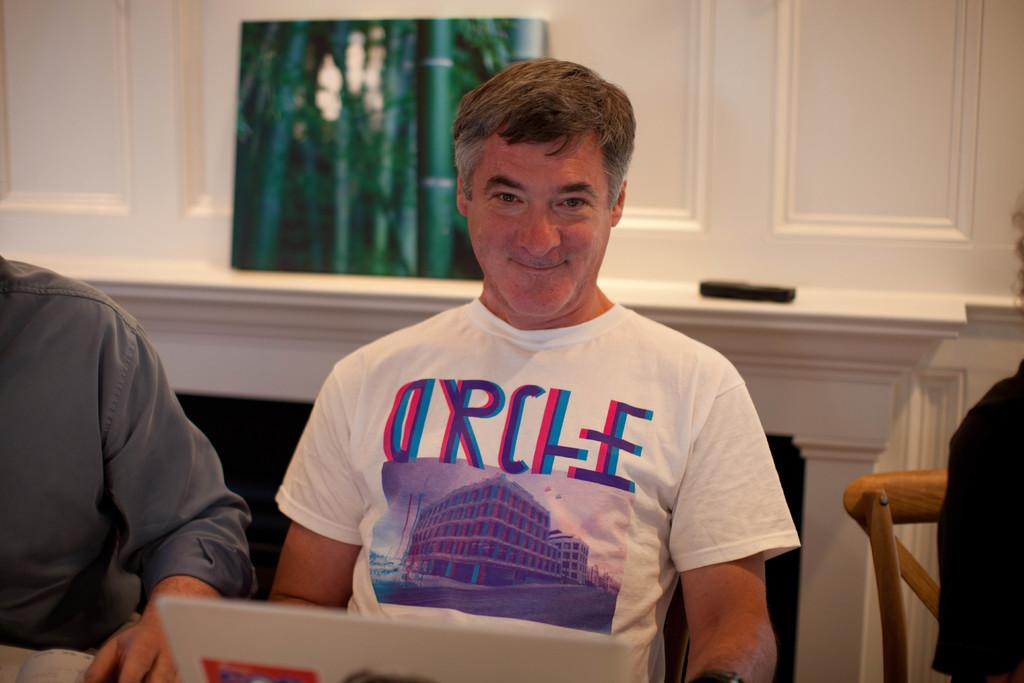What are the people in the image doing? The people in the image are sitting on chairs. What objects are in front of the people? There is a laptop and a book in front of the people. What can be seen at the back side of the image? There is a mirror and a phone at the back side of the image. What language is being spoken by the people in the image? The image does not provide any information about the language being spoken by the people. What shape is the table in the image? The image does not show a table, so it is impossible to determine its shape. 